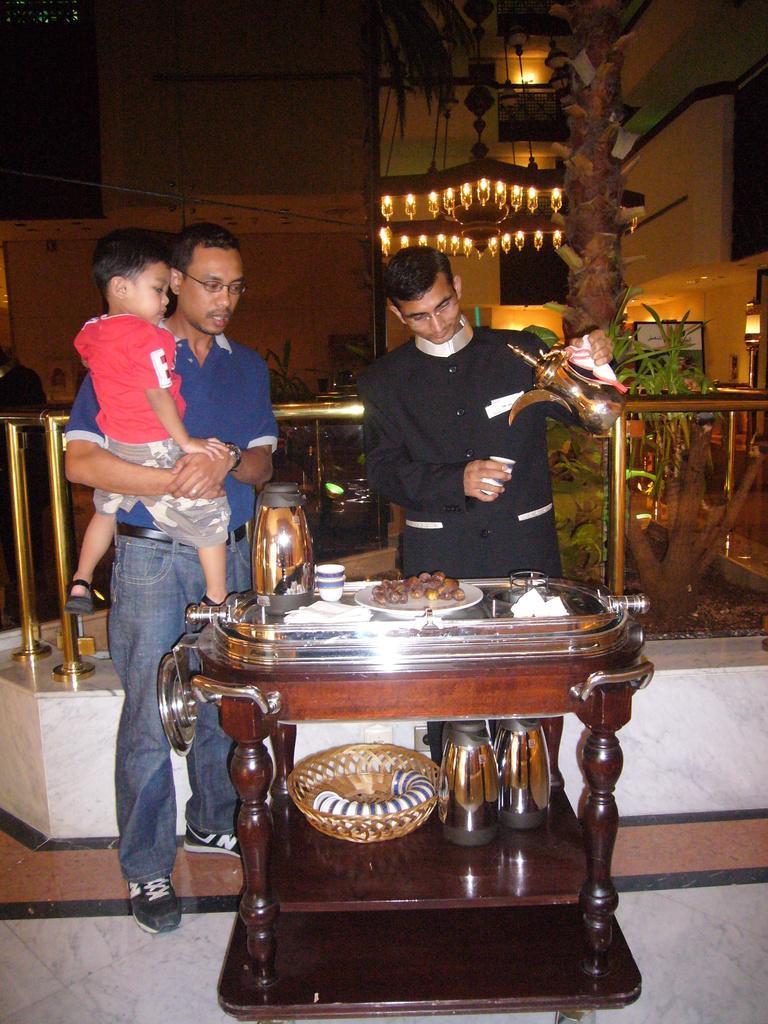How would you summarize this image in a sentence or two? This is the picture of a place where we have two people and a child standing in front of the table on which there are flask, bowl, plates, and some food items and behind them there is a tree and some lights to the wall. 